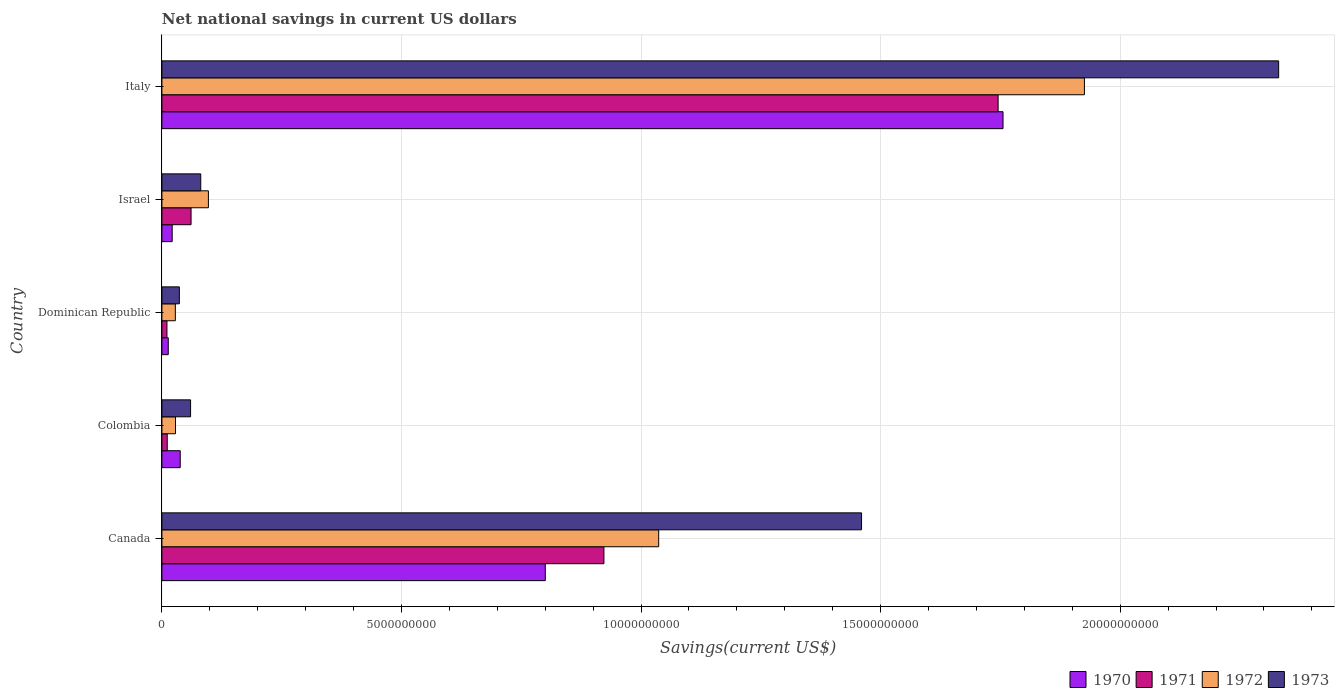How many groups of bars are there?
Make the answer very short. 5. What is the label of the 4th group of bars from the top?
Your response must be concise. Colombia. What is the net national savings in 1971 in Italy?
Make the answer very short. 1.75e+1. Across all countries, what is the maximum net national savings in 1972?
Provide a succinct answer. 1.93e+1. Across all countries, what is the minimum net national savings in 1970?
Provide a succinct answer. 1.33e+08. In which country was the net national savings in 1973 maximum?
Keep it short and to the point. Italy. In which country was the net national savings in 1970 minimum?
Offer a very short reply. Dominican Republic. What is the total net national savings in 1973 in the graph?
Provide a short and direct response. 3.97e+1. What is the difference between the net national savings in 1971 in Canada and that in Dominican Republic?
Ensure brevity in your answer.  9.12e+09. What is the difference between the net national savings in 1973 in Italy and the net national savings in 1971 in Canada?
Ensure brevity in your answer.  1.41e+1. What is the average net national savings in 1971 per country?
Keep it short and to the point. 5.50e+09. What is the difference between the net national savings in 1971 and net national savings in 1973 in Colombia?
Offer a very short reply. -4.87e+08. In how many countries, is the net national savings in 1971 greater than 1000000000 US$?
Give a very brief answer. 2. What is the ratio of the net national savings in 1973 in Israel to that in Italy?
Keep it short and to the point. 0.03. Is the difference between the net national savings in 1971 in Canada and Colombia greater than the difference between the net national savings in 1973 in Canada and Colombia?
Keep it short and to the point. No. What is the difference between the highest and the second highest net national savings in 1972?
Offer a terse response. 8.89e+09. What is the difference between the highest and the lowest net national savings in 1972?
Offer a terse response. 1.90e+1. In how many countries, is the net national savings in 1971 greater than the average net national savings in 1971 taken over all countries?
Keep it short and to the point. 2. Is the sum of the net national savings in 1973 in Canada and Dominican Republic greater than the maximum net national savings in 1972 across all countries?
Ensure brevity in your answer.  No. Is it the case that in every country, the sum of the net national savings in 1972 and net national savings in 1973 is greater than the sum of net national savings in 1970 and net national savings in 1971?
Provide a short and direct response. No. What does the 1st bar from the bottom in Colombia represents?
Your answer should be very brief. 1970. Is it the case that in every country, the sum of the net national savings in 1973 and net national savings in 1971 is greater than the net national savings in 1970?
Your answer should be compact. Yes. What is the difference between two consecutive major ticks on the X-axis?
Make the answer very short. 5.00e+09. Are the values on the major ticks of X-axis written in scientific E-notation?
Your response must be concise. No. Does the graph contain grids?
Keep it short and to the point. Yes. How many legend labels are there?
Give a very brief answer. 4. What is the title of the graph?
Your response must be concise. Net national savings in current US dollars. Does "2014" appear as one of the legend labels in the graph?
Make the answer very short. No. What is the label or title of the X-axis?
Offer a very short reply. Savings(current US$). What is the Savings(current US$) in 1970 in Canada?
Give a very brief answer. 8.00e+09. What is the Savings(current US$) in 1971 in Canada?
Provide a succinct answer. 9.23e+09. What is the Savings(current US$) of 1972 in Canada?
Give a very brief answer. 1.04e+1. What is the Savings(current US$) of 1973 in Canada?
Your answer should be very brief. 1.46e+1. What is the Savings(current US$) in 1970 in Colombia?
Keep it short and to the point. 3.83e+08. What is the Savings(current US$) of 1971 in Colombia?
Keep it short and to the point. 1.11e+08. What is the Savings(current US$) in 1972 in Colombia?
Your answer should be compact. 2.84e+08. What is the Savings(current US$) in 1973 in Colombia?
Ensure brevity in your answer.  5.98e+08. What is the Savings(current US$) in 1970 in Dominican Republic?
Your answer should be very brief. 1.33e+08. What is the Savings(current US$) in 1971 in Dominican Republic?
Ensure brevity in your answer.  1.05e+08. What is the Savings(current US$) in 1972 in Dominican Republic?
Keep it short and to the point. 2.80e+08. What is the Savings(current US$) of 1973 in Dominican Republic?
Provide a short and direct response. 3.65e+08. What is the Savings(current US$) of 1970 in Israel?
Offer a very short reply. 2.15e+08. What is the Savings(current US$) of 1971 in Israel?
Provide a short and direct response. 6.09e+08. What is the Savings(current US$) in 1972 in Israel?
Your response must be concise. 9.71e+08. What is the Savings(current US$) in 1973 in Israel?
Offer a terse response. 8.11e+08. What is the Savings(current US$) of 1970 in Italy?
Offer a very short reply. 1.76e+1. What is the Savings(current US$) of 1971 in Italy?
Your response must be concise. 1.75e+1. What is the Savings(current US$) of 1972 in Italy?
Your answer should be very brief. 1.93e+1. What is the Savings(current US$) of 1973 in Italy?
Your answer should be very brief. 2.33e+1. Across all countries, what is the maximum Savings(current US$) in 1970?
Ensure brevity in your answer.  1.76e+1. Across all countries, what is the maximum Savings(current US$) of 1971?
Your answer should be compact. 1.75e+1. Across all countries, what is the maximum Savings(current US$) of 1972?
Your answer should be very brief. 1.93e+1. Across all countries, what is the maximum Savings(current US$) in 1973?
Provide a succinct answer. 2.33e+1. Across all countries, what is the minimum Savings(current US$) of 1970?
Keep it short and to the point. 1.33e+08. Across all countries, what is the minimum Savings(current US$) of 1971?
Ensure brevity in your answer.  1.05e+08. Across all countries, what is the minimum Savings(current US$) of 1972?
Provide a succinct answer. 2.80e+08. Across all countries, what is the minimum Savings(current US$) in 1973?
Keep it short and to the point. 3.65e+08. What is the total Savings(current US$) of 1970 in the graph?
Your answer should be compact. 2.63e+1. What is the total Savings(current US$) of 1971 in the graph?
Keep it short and to the point. 2.75e+1. What is the total Savings(current US$) of 1972 in the graph?
Offer a very short reply. 3.12e+1. What is the total Savings(current US$) of 1973 in the graph?
Your response must be concise. 3.97e+1. What is the difference between the Savings(current US$) in 1970 in Canada and that in Colombia?
Provide a short and direct response. 7.62e+09. What is the difference between the Savings(current US$) in 1971 in Canada and that in Colombia?
Your answer should be very brief. 9.11e+09. What is the difference between the Savings(current US$) of 1972 in Canada and that in Colombia?
Provide a succinct answer. 1.01e+1. What is the difference between the Savings(current US$) in 1973 in Canada and that in Colombia?
Offer a very short reply. 1.40e+1. What is the difference between the Savings(current US$) of 1970 in Canada and that in Dominican Republic?
Give a very brief answer. 7.87e+09. What is the difference between the Savings(current US$) in 1971 in Canada and that in Dominican Republic?
Provide a short and direct response. 9.12e+09. What is the difference between the Savings(current US$) of 1972 in Canada and that in Dominican Republic?
Your answer should be compact. 1.01e+1. What is the difference between the Savings(current US$) of 1973 in Canada and that in Dominican Republic?
Your answer should be compact. 1.42e+1. What is the difference between the Savings(current US$) of 1970 in Canada and that in Israel?
Provide a succinct answer. 7.79e+09. What is the difference between the Savings(current US$) in 1971 in Canada and that in Israel?
Give a very brief answer. 8.62e+09. What is the difference between the Savings(current US$) of 1972 in Canada and that in Israel?
Ensure brevity in your answer.  9.40e+09. What is the difference between the Savings(current US$) of 1973 in Canada and that in Israel?
Your answer should be very brief. 1.38e+1. What is the difference between the Savings(current US$) of 1970 in Canada and that in Italy?
Ensure brevity in your answer.  -9.55e+09. What is the difference between the Savings(current US$) in 1971 in Canada and that in Italy?
Make the answer very short. -8.23e+09. What is the difference between the Savings(current US$) of 1972 in Canada and that in Italy?
Make the answer very short. -8.89e+09. What is the difference between the Savings(current US$) of 1973 in Canada and that in Italy?
Your response must be concise. -8.71e+09. What is the difference between the Savings(current US$) in 1970 in Colombia and that in Dominican Republic?
Offer a terse response. 2.50e+08. What is the difference between the Savings(current US$) of 1971 in Colombia and that in Dominican Republic?
Your answer should be very brief. 6.03e+06. What is the difference between the Savings(current US$) of 1972 in Colombia and that in Dominican Republic?
Your answer should be very brief. 3.48e+06. What is the difference between the Savings(current US$) in 1973 in Colombia and that in Dominican Republic?
Provide a succinct answer. 2.34e+08. What is the difference between the Savings(current US$) of 1970 in Colombia and that in Israel?
Ensure brevity in your answer.  1.68e+08. What is the difference between the Savings(current US$) of 1971 in Colombia and that in Israel?
Offer a very short reply. -4.97e+08. What is the difference between the Savings(current US$) of 1972 in Colombia and that in Israel?
Your answer should be compact. -6.87e+08. What is the difference between the Savings(current US$) in 1973 in Colombia and that in Israel?
Keep it short and to the point. -2.12e+08. What is the difference between the Savings(current US$) in 1970 in Colombia and that in Italy?
Your answer should be very brief. -1.72e+1. What is the difference between the Savings(current US$) of 1971 in Colombia and that in Italy?
Offer a very short reply. -1.73e+1. What is the difference between the Savings(current US$) of 1972 in Colombia and that in Italy?
Keep it short and to the point. -1.90e+1. What is the difference between the Savings(current US$) in 1973 in Colombia and that in Italy?
Keep it short and to the point. -2.27e+1. What is the difference between the Savings(current US$) in 1970 in Dominican Republic and that in Israel?
Your response must be concise. -8.19e+07. What is the difference between the Savings(current US$) in 1971 in Dominican Republic and that in Israel?
Provide a succinct answer. -5.03e+08. What is the difference between the Savings(current US$) of 1972 in Dominican Republic and that in Israel?
Your answer should be compact. -6.90e+08. What is the difference between the Savings(current US$) of 1973 in Dominican Republic and that in Israel?
Ensure brevity in your answer.  -4.46e+08. What is the difference between the Savings(current US$) in 1970 in Dominican Republic and that in Italy?
Your answer should be very brief. -1.74e+1. What is the difference between the Savings(current US$) in 1971 in Dominican Republic and that in Italy?
Provide a succinct answer. -1.73e+1. What is the difference between the Savings(current US$) of 1972 in Dominican Republic and that in Italy?
Offer a terse response. -1.90e+1. What is the difference between the Savings(current US$) in 1973 in Dominican Republic and that in Italy?
Make the answer very short. -2.29e+1. What is the difference between the Savings(current US$) in 1970 in Israel and that in Italy?
Provide a short and direct response. -1.73e+1. What is the difference between the Savings(current US$) in 1971 in Israel and that in Italy?
Offer a terse response. -1.68e+1. What is the difference between the Savings(current US$) of 1972 in Israel and that in Italy?
Offer a terse response. -1.83e+1. What is the difference between the Savings(current US$) in 1973 in Israel and that in Italy?
Provide a short and direct response. -2.25e+1. What is the difference between the Savings(current US$) in 1970 in Canada and the Savings(current US$) in 1971 in Colombia?
Your answer should be very brief. 7.89e+09. What is the difference between the Savings(current US$) of 1970 in Canada and the Savings(current US$) of 1972 in Colombia?
Give a very brief answer. 7.72e+09. What is the difference between the Savings(current US$) in 1970 in Canada and the Savings(current US$) in 1973 in Colombia?
Your answer should be very brief. 7.40e+09. What is the difference between the Savings(current US$) of 1971 in Canada and the Savings(current US$) of 1972 in Colombia?
Offer a terse response. 8.94e+09. What is the difference between the Savings(current US$) in 1971 in Canada and the Savings(current US$) in 1973 in Colombia?
Your answer should be compact. 8.63e+09. What is the difference between the Savings(current US$) of 1972 in Canada and the Savings(current US$) of 1973 in Colombia?
Your response must be concise. 9.77e+09. What is the difference between the Savings(current US$) in 1970 in Canada and the Savings(current US$) in 1971 in Dominican Republic?
Offer a terse response. 7.90e+09. What is the difference between the Savings(current US$) in 1970 in Canada and the Savings(current US$) in 1972 in Dominican Republic?
Your response must be concise. 7.72e+09. What is the difference between the Savings(current US$) in 1970 in Canada and the Savings(current US$) in 1973 in Dominican Republic?
Provide a short and direct response. 7.64e+09. What is the difference between the Savings(current US$) of 1971 in Canada and the Savings(current US$) of 1972 in Dominican Republic?
Your answer should be very brief. 8.94e+09. What is the difference between the Savings(current US$) in 1971 in Canada and the Savings(current US$) in 1973 in Dominican Republic?
Provide a succinct answer. 8.86e+09. What is the difference between the Savings(current US$) of 1972 in Canada and the Savings(current US$) of 1973 in Dominican Republic?
Keep it short and to the point. 1.00e+1. What is the difference between the Savings(current US$) of 1970 in Canada and the Savings(current US$) of 1971 in Israel?
Make the answer very short. 7.39e+09. What is the difference between the Savings(current US$) of 1970 in Canada and the Savings(current US$) of 1972 in Israel?
Keep it short and to the point. 7.03e+09. What is the difference between the Savings(current US$) in 1970 in Canada and the Savings(current US$) in 1973 in Israel?
Keep it short and to the point. 7.19e+09. What is the difference between the Savings(current US$) of 1971 in Canada and the Savings(current US$) of 1972 in Israel?
Offer a very short reply. 8.25e+09. What is the difference between the Savings(current US$) in 1971 in Canada and the Savings(current US$) in 1973 in Israel?
Ensure brevity in your answer.  8.41e+09. What is the difference between the Savings(current US$) in 1972 in Canada and the Savings(current US$) in 1973 in Israel?
Your response must be concise. 9.56e+09. What is the difference between the Savings(current US$) in 1970 in Canada and the Savings(current US$) in 1971 in Italy?
Provide a succinct answer. -9.45e+09. What is the difference between the Savings(current US$) of 1970 in Canada and the Savings(current US$) of 1972 in Italy?
Provide a succinct answer. -1.13e+1. What is the difference between the Savings(current US$) of 1970 in Canada and the Savings(current US$) of 1973 in Italy?
Your answer should be very brief. -1.53e+1. What is the difference between the Savings(current US$) of 1971 in Canada and the Savings(current US$) of 1972 in Italy?
Make the answer very short. -1.00e+1. What is the difference between the Savings(current US$) of 1971 in Canada and the Savings(current US$) of 1973 in Italy?
Ensure brevity in your answer.  -1.41e+1. What is the difference between the Savings(current US$) of 1972 in Canada and the Savings(current US$) of 1973 in Italy?
Provide a short and direct response. -1.29e+1. What is the difference between the Savings(current US$) in 1970 in Colombia and the Savings(current US$) in 1971 in Dominican Republic?
Your response must be concise. 2.77e+08. What is the difference between the Savings(current US$) in 1970 in Colombia and the Savings(current US$) in 1972 in Dominican Republic?
Your answer should be compact. 1.02e+08. What is the difference between the Savings(current US$) of 1970 in Colombia and the Savings(current US$) of 1973 in Dominican Republic?
Your answer should be compact. 1.82e+07. What is the difference between the Savings(current US$) of 1971 in Colombia and the Savings(current US$) of 1972 in Dominican Republic?
Offer a very short reply. -1.69e+08. What is the difference between the Savings(current US$) of 1971 in Colombia and the Savings(current US$) of 1973 in Dominican Republic?
Your response must be concise. -2.53e+08. What is the difference between the Savings(current US$) of 1972 in Colombia and the Savings(current US$) of 1973 in Dominican Republic?
Keep it short and to the point. -8.05e+07. What is the difference between the Savings(current US$) of 1970 in Colombia and the Savings(current US$) of 1971 in Israel?
Your answer should be very brief. -2.26e+08. What is the difference between the Savings(current US$) of 1970 in Colombia and the Savings(current US$) of 1972 in Israel?
Your answer should be compact. -5.88e+08. What is the difference between the Savings(current US$) of 1970 in Colombia and the Savings(current US$) of 1973 in Israel?
Your response must be concise. -4.28e+08. What is the difference between the Savings(current US$) of 1971 in Colombia and the Savings(current US$) of 1972 in Israel?
Ensure brevity in your answer.  -8.59e+08. What is the difference between the Savings(current US$) in 1971 in Colombia and the Savings(current US$) in 1973 in Israel?
Keep it short and to the point. -6.99e+08. What is the difference between the Savings(current US$) of 1972 in Colombia and the Savings(current US$) of 1973 in Israel?
Provide a succinct answer. -5.27e+08. What is the difference between the Savings(current US$) of 1970 in Colombia and the Savings(current US$) of 1971 in Italy?
Offer a terse response. -1.71e+1. What is the difference between the Savings(current US$) of 1970 in Colombia and the Savings(current US$) of 1972 in Italy?
Keep it short and to the point. -1.89e+1. What is the difference between the Savings(current US$) of 1970 in Colombia and the Savings(current US$) of 1973 in Italy?
Keep it short and to the point. -2.29e+1. What is the difference between the Savings(current US$) in 1971 in Colombia and the Savings(current US$) in 1972 in Italy?
Your response must be concise. -1.91e+1. What is the difference between the Savings(current US$) of 1971 in Colombia and the Savings(current US$) of 1973 in Italy?
Ensure brevity in your answer.  -2.32e+1. What is the difference between the Savings(current US$) of 1972 in Colombia and the Savings(current US$) of 1973 in Italy?
Your response must be concise. -2.30e+1. What is the difference between the Savings(current US$) in 1970 in Dominican Republic and the Savings(current US$) in 1971 in Israel?
Make the answer very short. -4.76e+08. What is the difference between the Savings(current US$) of 1970 in Dominican Republic and the Savings(current US$) of 1972 in Israel?
Give a very brief answer. -8.38e+08. What is the difference between the Savings(current US$) of 1970 in Dominican Republic and the Savings(current US$) of 1973 in Israel?
Your response must be concise. -6.78e+08. What is the difference between the Savings(current US$) of 1971 in Dominican Republic and the Savings(current US$) of 1972 in Israel?
Provide a succinct answer. -8.65e+08. What is the difference between the Savings(current US$) of 1971 in Dominican Republic and the Savings(current US$) of 1973 in Israel?
Give a very brief answer. -7.05e+08. What is the difference between the Savings(current US$) of 1972 in Dominican Republic and the Savings(current US$) of 1973 in Israel?
Your response must be concise. -5.30e+08. What is the difference between the Savings(current US$) of 1970 in Dominican Republic and the Savings(current US$) of 1971 in Italy?
Provide a succinct answer. -1.73e+1. What is the difference between the Savings(current US$) in 1970 in Dominican Republic and the Savings(current US$) in 1972 in Italy?
Your answer should be very brief. -1.91e+1. What is the difference between the Savings(current US$) of 1970 in Dominican Republic and the Savings(current US$) of 1973 in Italy?
Provide a short and direct response. -2.32e+1. What is the difference between the Savings(current US$) in 1971 in Dominican Republic and the Savings(current US$) in 1972 in Italy?
Give a very brief answer. -1.91e+1. What is the difference between the Savings(current US$) of 1971 in Dominican Republic and the Savings(current US$) of 1973 in Italy?
Your response must be concise. -2.32e+1. What is the difference between the Savings(current US$) of 1972 in Dominican Republic and the Savings(current US$) of 1973 in Italy?
Make the answer very short. -2.30e+1. What is the difference between the Savings(current US$) of 1970 in Israel and the Savings(current US$) of 1971 in Italy?
Offer a very short reply. -1.72e+1. What is the difference between the Savings(current US$) of 1970 in Israel and the Savings(current US$) of 1972 in Italy?
Provide a succinct answer. -1.90e+1. What is the difference between the Savings(current US$) of 1970 in Israel and the Savings(current US$) of 1973 in Italy?
Your answer should be compact. -2.31e+1. What is the difference between the Savings(current US$) of 1971 in Israel and the Savings(current US$) of 1972 in Italy?
Make the answer very short. -1.86e+1. What is the difference between the Savings(current US$) of 1971 in Israel and the Savings(current US$) of 1973 in Italy?
Your answer should be very brief. -2.27e+1. What is the difference between the Savings(current US$) in 1972 in Israel and the Savings(current US$) in 1973 in Italy?
Provide a succinct answer. -2.23e+1. What is the average Savings(current US$) of 1970 per country?
Offer a terse response. 5.26e+09. What is the average Savings(current US$) in 1971 per country?
Offer a very short reply. 5.50e+09. What is the average Savings(current US$) of 1972 per country?
Provide a short and direct response. 6.23e+09. What is the average Savings(current US$) in 1973 per country?
Keep it short and to the point. 7.94e+09. What is the difference between the Savings(current US$) in 1970 and Savings(current US$) in 1971 in Canada?
Provide a short and direct response. -1.22e+09. What is the difference between the Savings(current US$) of 1970 and Savings(current US$) of 1972 in Canada?
Ensure brevity in your answer.  -2.37e+09. What is the difference between the Savings(current US$) of 1970 and Savings(current US$) of 1973 in Canada?
Give a very brief answer. -6.60e+09. What is the difference between the Savings(current US$) in 1971 and Savings(current US$) in 1972 in Canada?
Keep it short and to the point. -1.14e+09. What is the difference between the Savings(current US$) in 1971 and Savings(current US$) in 1973 in Canada?
Ensure brevity in your answer.  -5.38e+09. What is the difference between the Savings(current US$) of 1972 and Savings(current US$) of 1973 in Canada?
Offer a very short reply. -4.23e+09. What is the difference between the Savings(current US$) of 1970 and Savings(current US$) of 1971 in Colombia?
Give a very brief answer. 2.71e+08. What is the difference between the Savings(current US$) of 1970 and Savings(current US$) of 1972 in Colombia?
Your answer should be very brief. 9.87e+07. What is the difference between the Savings(current US$) in 1970 and Savings(current US$) in 1973 in Colombia?
Offer a very short reply. -2.16e+08. What is the difference between the Savings(current US$) in 1971 and Savings(current US$) in 1972 in Colombia?
Provide a short and direct response. -1.73e+08. What is the difference between the Savings(current US$) in 1971 and Savings(current US$) in 1973 in Colombia?
Offer a very short reply. -4.87e+08. What is the difference between the Savings(current US$) in 1972 and Savings(current US$) in 1973 in Colombia?
Your response must be concise. -3.14e+08. What is the difference between the Savings(current US$) in 1970 and Savings(current US$) in 1971 in Dominican Republic?
Your answer should be compact. 2.74e+07. What is the difference between the Savings(current US$) of 1970 and Savings(current US$) of 1972 in Dominican Republic?
Keep it short and to the point. -1.48e+08. What is the difference between the Savings(current US$) of 1970 and Savings(current US$) of 1973 in Dominican Republic?
Make the answer very short. -2.32e+08. What is the difference between the Savings(current US$) in 1971 and Savings(current US$) in 1972 in Dominican Republic?
Provide a short and direct response. -1.75e+08. What is the difference between the Savings(current US$) of 1971 and Savings(current US$) of 1973 in Dominican Republic?
Make the answer very short. -2.59e+08. What is the difference between the Savings(current US$) of 1972 and Savings(current US$) of 1973 in Dominican Republic?
Offer a very short reply. -8.40e+07. What is the difference between the Savings(current US$) in 1970 and Savings(current US$) in 1971 in Israel?
Your answer should be compact. -3.94e+08. What is the difference between the Savings(current US$) of 1970 and Savings(current US$) of 1972 in Israel?
Offer a terse response. -7.56e+08. What is the difference between the Savings(current US$) of 1970 and Savings(current US$) of 1973 in Israel?
Ensure brevity in your answer.  -5.96e+08. What is the difference between the Savings(current US$) in 1971 and Savings(current US$) in 1972 in Israel?
Give a very brief answer. -3.62e+08. What is the difference between the Savings(current US$) of 1971 and Savings(current US$) of 1973 in Israel?
Provide a succinct answer. -2.02e+08. What is the difference between the Savings(current US$) of 1972 and Savings(current US$) of 1973 in Israel?
Offer a very short reply. 1.60e+08. What is the difference between the Savings(current US$) of 1970 and Savings(current US$) of 1971 in Italy?
Offer a very short reply. 1.03e+08. What is the difference between the Savings(current US$) in 1970 and Savings(current US$) in 1972 in Italy?
Provide a short and direct response. -1.70e+09. What is the difference between the Savings(current US$) of 1970 and Savings(current US$) of 1973 in Italy?
Your response must be concise. -5.75e+09. What is the difference between the Savings(current US$) of 1971 and Savings(current US$) of 1972 in Italy?
Give a very brief answer. -1.80e+09. What is the difference between the Savings(current US$) of 1971 and Savings(current US$) of 1973 in Italy?
Ensure brevity in your answer.  -5.86e+09. What is the difference between the Savings(current US$) of 1972 and Savings(current US$) of 1973 in Italy?
Ensure brevity in your answer.  -4.05e+09. What is the ratio of the Savings(current US$) in 1970 in Canada to that in Colombia?
Your answer should be compact. 20.91. What is the ratio of the Savings(current US$) in 1971 in Canada to that in Colombia?
Keep it short and to the point. 82.79. What is the ratio of the Savings(current US$) of 1972 in Canada to that in Colombia?
Make the answer very short. 36.51. What is the ratio of the Savings(current US$) of 1973 in Canada to that in Colombia?
Give a very brief answer. 24.4. What is the ratio of the Savings(current US$) of 1970 in Canada to that in Dominican Republic?
Offer a terse response. 60.27. What is the ratio of the Savings(current US$) in 1971 in Canada to that in Dominican Republic?
Offer a terse response. 87.52. What is the ratio of the Savings(current US$) in 1972 in Canada to that in Dominican Republic?
Provide a succinct answer. 36.96. What is the ratio of the Savings(current US$) in 1973 in Canada to that in Dominican Republic?
Give a very brief answer. 40.06. What is the ratio of the Savings(current US$) in 1970 in Canada to that in Israel?
Make the answer very short. 37.28. What is the ratio of the Savings(current US$) of 1971 in Canada to that in Israel?
Provide a succinct answer. 15.16. What is the ratio of the Savings(current US$) of 1972 in Canada to that in Israel?
Your answer should be very brief. 10.68. What is the ratio of the Savings(current US$) of 1973 in Canada to that in Israel?
Provide a succinct answer. 18.01. What is the ratio of the Savings(current US$) of 1970 in Canada to that in Italy?
Ensure brevity in your answer.  0.46. What is the ratio of the Savings(current US$) of 1971 in Canada to that in Italy?
Your answer should be compact. 0.53. What is the ratio of the Savings(current US$) of 1972 in Canada to that in Italy?
Provide a succinct answer. 0.54. What is the ratio of the Savings(current US$) in 1973 in Canada to that in Italy?
Offer a terse response. 0.63. What is the ratio of the Savings(current US$) in 1970 in Colombia to that in Dominican Republic?
Ensure brevity in your answer.  2.88. What is the ratio of the Savings(current US$) in 1971 in Colombia to that in Dominican Republic?
Make the answer very short. 1.06. What is the ratio of the Savings(current US$) of 1972 in Colombia to that in Dominican Republic?
Your response must be concise. 1.01. What is the ratio of the Savings(current US$) in 1973 in Colombia to that in Dominican Republic?
Your answer should be compact. 1.64. What is the ratio of the Savings(current US$) of 1970 in Colombia to that in Israel?
Give a very brief answer. 1.78. What is the ratio of the Savings(current US$) in 1971 in Colombia to that in Israel?
Provide a short and direct response. 0.18. What is the ratio of the Savings(current US$) of 1972 in Colombia to that in Israel?
Provide a succinct answer. 0.29. What is the ratio of the Savings(current US$) in 1973 in Colombia to that in Israel?
Your answer should be very brief. 0.74. What is the ratio of the Savings(current US$) of 1970 in Colombia to that in Italy?
Provide a short and direct response. 0.02. What is the ratio of the Savings(current US$) in 1971 in Colombia to that in Italy?
Provide a succinct answer. 0.01. What is the ratio of the Savings(current US$) of 1972 in Colombia to that in Italy?
Offer a very short reply. 0.01. What is the ratio of the Savings(current US$) in 1973 in Colombia to that in Italy?
Your answer should be compact. 0.03. What is the ratio of the Savings(current US$) in 1970 in Dominican Republic to that in Israel?
Offer a terse response. 0.62. What is the ratio of the Savings(current US$) in 1971 in Dominican Republic to that in Israel?
Give a very brief answer. 0.17. What is the ratio of the Savings(current US$) of 1972 in Dominican Republic to that in Israel?
Give a very brief answer. 0.29. What is the ratio of the Savings(current US$) of 1973 in Dominican Republic to that in Israel?
Offer a terse response. 0.45. What is the ratio of the Savings(current US$) of 1970 in Dominican Republic to that in Italy?
Offer a very short reply. 0.01. What is the ratio of the Savings(current US$) in 1971 in Dominican Republic to that in Italy?
Make the answer very short. 0.01. What is the ratio of the Savings(current US$) in 1972 in Dominican Republic to that in Italy?
Offer a terse response. 0.01. What is the ratio of the Savings(current US$) in 1973 in Dominican Republic to that in Italy?
Your response must be concise. 0.02. What is the ratio of the Savings(current US$) in 1970 in Israel to that in Italy?
Provide a succinct answer. 0.01. What is the ratio of the Savings(current US$) in 1971 in Israel to that in Italy?
Your answer should be compact. 0.03. What is the ratio of the Savings(current US$) in 1972 in Israel to that in Italy?
Your answer should be compact. 0.05. What is the ratio of the Savings(current US$) in 1973 in Israel to that in Italy?
Make the answer very short. 0.03. What is the difference between the highest and the second highest Savings(current US$) in 1970?
Provide a short and direct response. 9.55e+09. What is the difference between the highest and the second highest Savings(current US$) of 1971?
Provide a short and direct response. 8.23e+09. What is the difference between the highest and the second highest Savings(current US$) in 1972?
Make the answer very short. 8.89e+09. What is the difference between the highest and the second highest Savings(current US$) of 1973?
Ensure brevity in your answer.  8.71e+09. What is the difference between the highest and the lowest Savings(current US$) in 1970?
Your answer should be very brief. 1.74e+1. What is the difference between the highest and the lowest Savings(current US$) in 1971?
Your response must be concise. 1.73e+1. What is the difference between the highest and the lowest Savings(current US$) of 1972?
Your response must be concise. 1.90e+1. What is the difference between the highest and the lowest Savings(current US$) in 1973?
Offer a very short reply. 2.29e+1. 